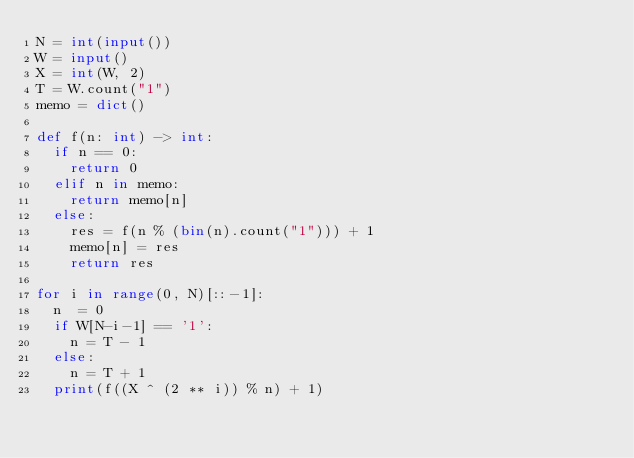Convert code to text. <code><loc_0><loc_0><loc_500><loc_500><_Python_>N = int(input())
W = input()
X = int(W, 2)
T = W.count("1")
memo = dict()

def f(n: int) -> int:
  if n == 0:
    return 0
  elif n in memo:
    return memo[n]
  else:
    res = f(n % (bin(n).count("1"))) + 1
    memo[n] = res
    return res

for i in range(0, N)[::-1]:
  n  = 0
  if W[N-i-1] == '1':
    n = T - 1
  else:
    n = T + 1
  print(f((X ^ (2 ** i)) % n) + 1)</code> 